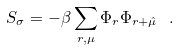<formula> <loc_0><loc_0><loc_500><loc_500>S _ { \sigma } = - \beta \sum _ { r , \mu } { \Phi } _ { r } { \Phi } _ { r + \hat { \mu } } \ .</formula> 